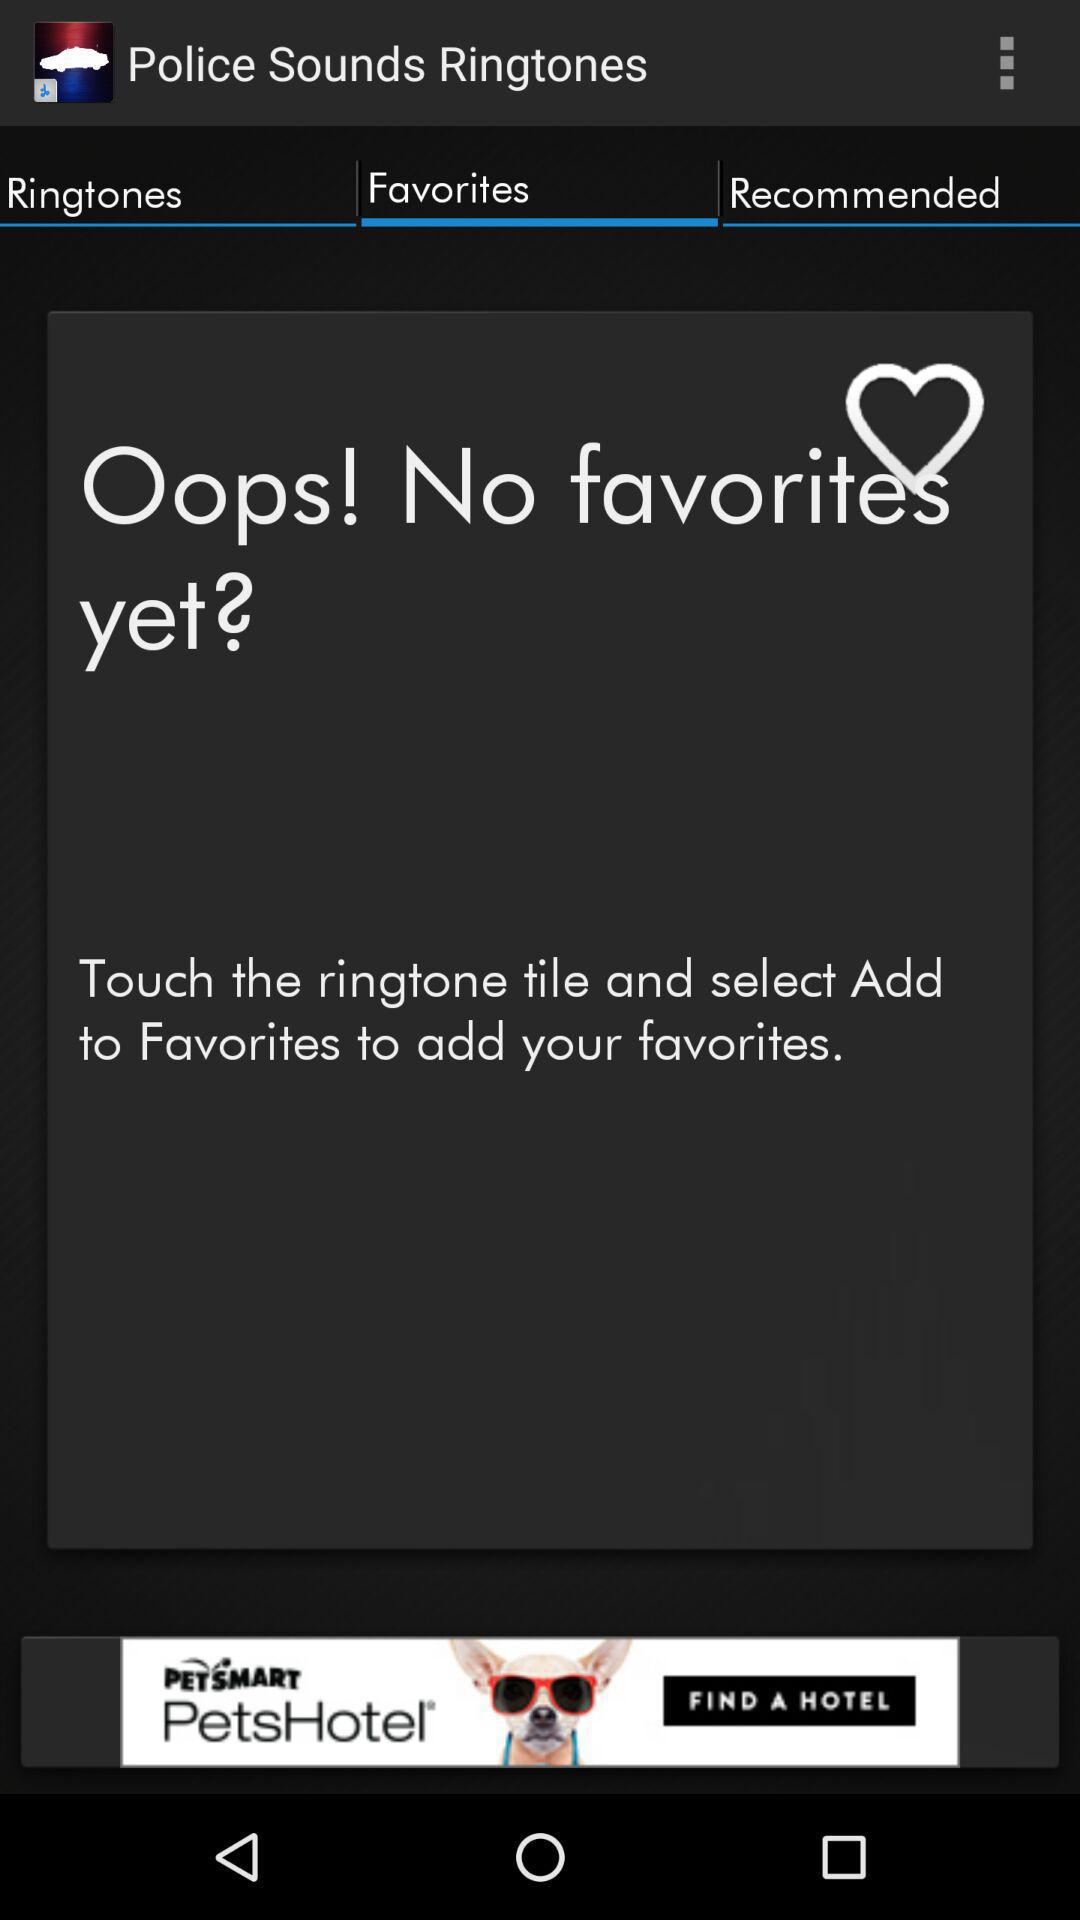What is the application name? The application name is "Police Sounds Ringtones". 